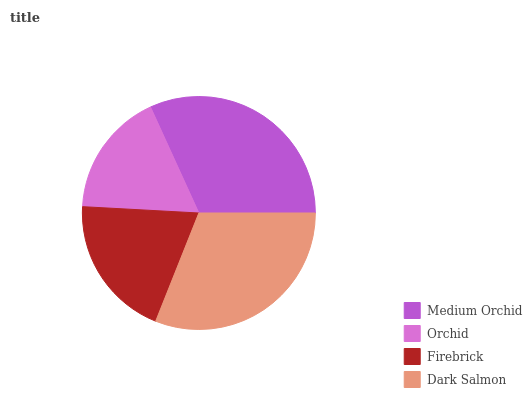Is Orchid the minimum?
Answer yes or no. Yes. Is Medium Orchid the maximum?
Answer yes or no. Yes. Is Firebrick the minimum?
Answer yes or no. No. Is Firebrick the maximum?
Answer yes or no. No. Is Firebrick greater than Orchid?
Answer yes or no. Yes. Is Orchid less than Firebrick?
Answer yes or no. Yes. Is Orchid greater than Firebrick?
Answer yes or no. No. Is Firebrick less than Orchid?
Answer yes or no. No. Is Dark Salmon the high median?
Answer yes or no. Yes. Is Firebrick the low median?
Answer yes or no. Yes. Is Orchid the high median?
Answer yes or no. No. Is Orchid the low median?
Answer yes or no. No. 